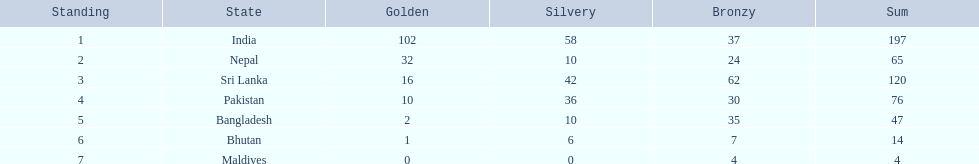What is the difference between the nation with the most medals and the nation with the least amount of medals? 193. 